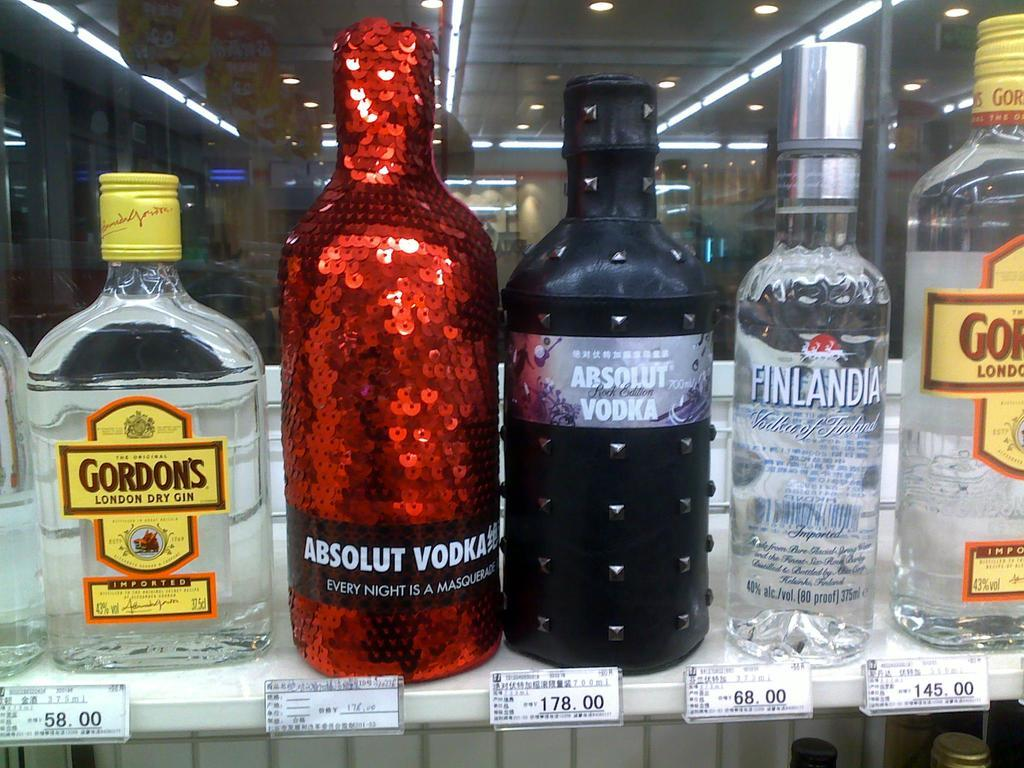<image>
Render a clear and concise summary of the photo. the name Gordon's that is on a clear bottle 